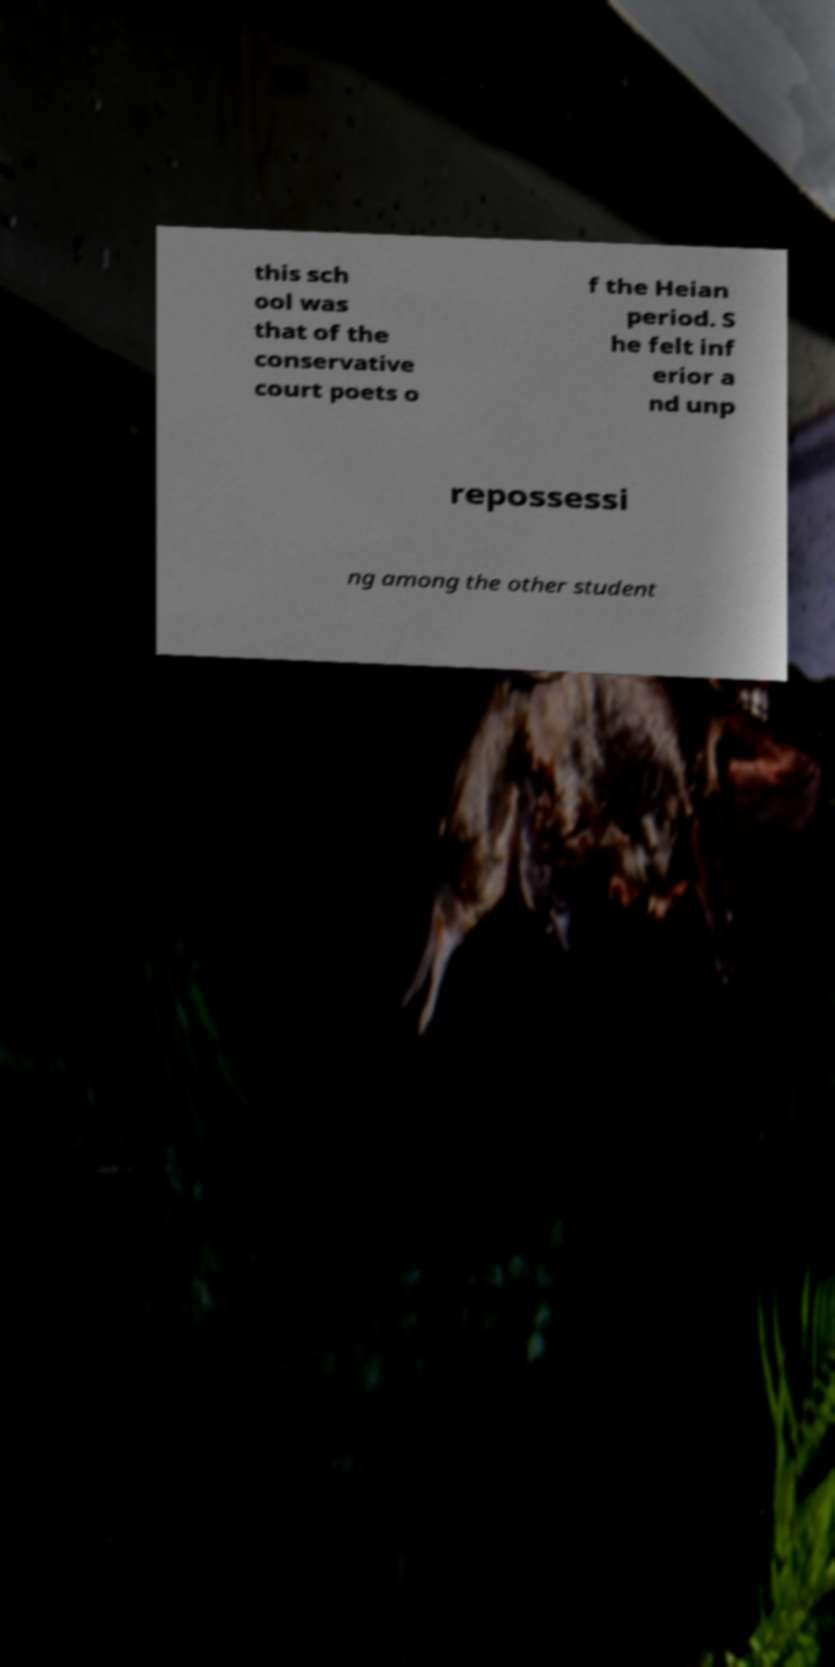There's text embedded in this image that I need extracted. Can you transcribe it verbatim? this sch ool was that of the conservative court poets o f the Heian period. S he felt inf erior a nd unp repossessi ng among the other student 